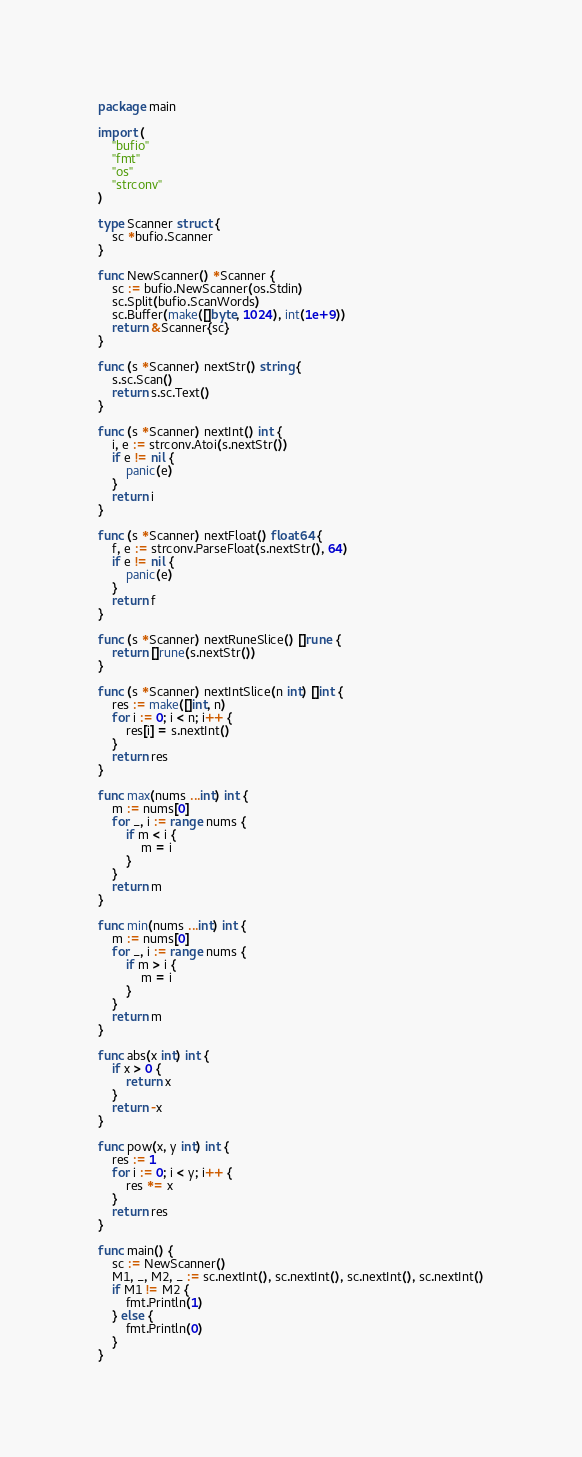Convert code to text. <code><loc_0><loc_0><loc_500><loc_500><_Go_>package main

import (
	"bufio"
	"fmt"
	"os"
	"strconv"
)

type Scanner struct {
	sc *bufio.Scanner
}

func NewScanner() *Scanner {
	sc := bufio.NewScanner(os.Stdin)
	sc.Split(bufio.ScanWords)
	sc.Buffer(make([]byte, 1024), int(1e+9))
	return &Scanner{sc}
}

func (s *Scanner) nextStr() string {
	s.sc.Scan()
	return s.sc.Text()
}

func (s *Scanner) nextInt() int {
	i, e := strconv.Atoi(s.nextStr())
	if e != nil {
		panic(e)
	}
	return i
}

func (s *Scanner) nextFloat() float64 {
	f, e := strconv.ParseFloat(s.nextStr(), 64)
	if e != nil {
		panic(e)
	}
	return f
}

func (s *Scanner) nextRuneSlice() []rune {
	return []rune(s.nextStr())
}

func (s *Scanner) nextIntSlice(n int) []int {
	res := make([]int, n)
	for i := 0; i < n; i++ {
		res[i] = s.nextInt()
	}
	return res
}

func max(nums ...int) int {
	m := nums[0]
	for _, i := range nums {
		if m < i {
			m = i
		}
	}
	return m
}

func min(nums ...int) int {
	m := nums[0]
	for _, i := range nums {
		if m > i {
			m = i
		}
	}
	return m
}

func abs(x int) int {
	if x > 0 {
		return x
	}
	return -x
}

func pow(x, y int) int {
	res := 1
	for i := 0; i < y; i++ {
		res *= x
	}
	return res
}

func main() {
	sc := NewScanner()
	M1, _, M2, _ := sc.nextInt(), sc.nextInt(), sc.nextInt(), sc.nextInt()
	if M1 != M2 {
		fmt.Println(1)
	} else {
		fmt.Println(0)
	}
}
</code> 